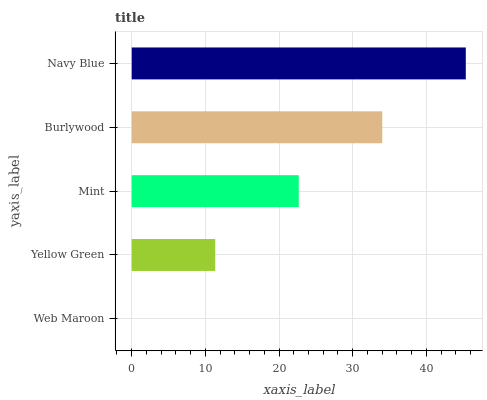Is Web Maroon the minimum?
Answer yes or no. Yes. Is Navy Blue the maximum?
Answer yes or no. Yes. Is Yellow Green the minimum?
Answer yes or no. No. Is Yellow Green the maximum?
Answer yes or no. No. Is Yellow Green greater than Web Maroon?
Answer yes or no. Yes. Is Web Maroon less than Yellow Green?
Answer yes or no. Yes. Is Web Maroon greater than Yellow Green?
Answer yes or no. No. Is Yellow Green less than Web Maroon?
Answer yes or no. No. Is Mint the high median?
Answer yes or no. Yes. Is Mint the low median?
Answer yes or no. Yes. Is Navy Blue the high median?
Answer yes or no. No. Is Burlywood the low median?
Answer yes or no. No. 